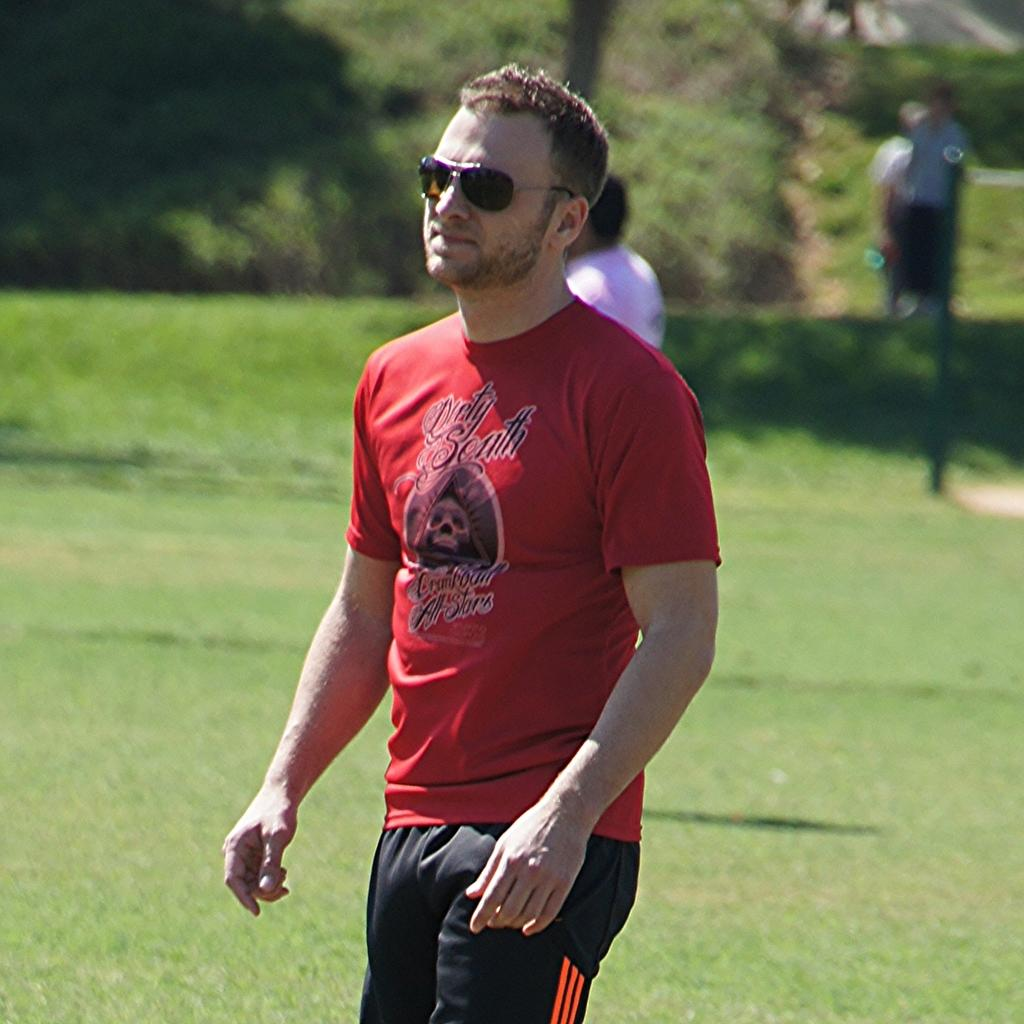What is the main subject in the foreground of the image? There is a man standing in the foreground of the image. What is the location of the people in the image? The people are on the grassland in the image. What can be seen in the background of the image? There is greenery in the background of the image. What word does the man in the image say to the trees in the background? There is no indication in the image that the man is saying anything to the trees, and therefore no such interaction can be observed. 